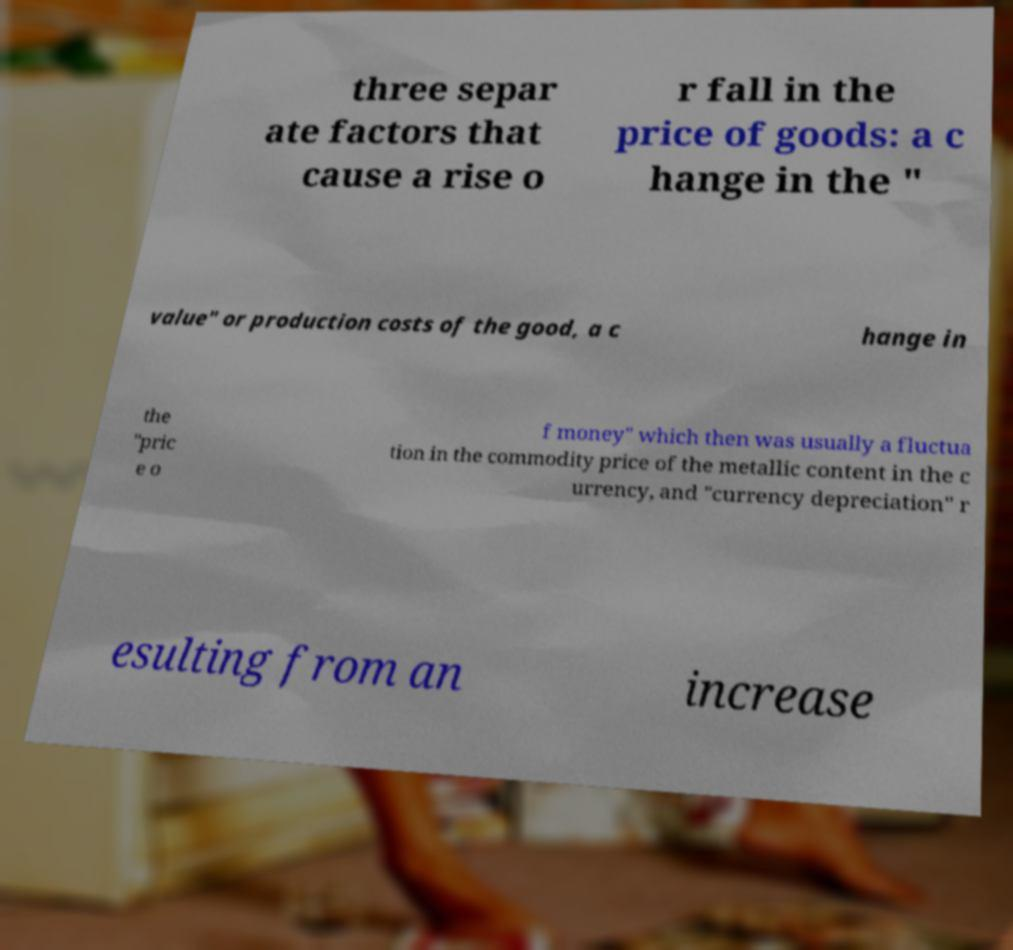I need the written content from this picture converted into text. Can you do that? three separ ate factors that cause a rise o r fall in the price of goods: a c hange in the " value" or production costs of the good, a c hange in the "pric e o f money" which then was usually a fluctua tion in the commodity price of the metallic content in the c urrency, and "currency depreciation" r esulting from an increase 